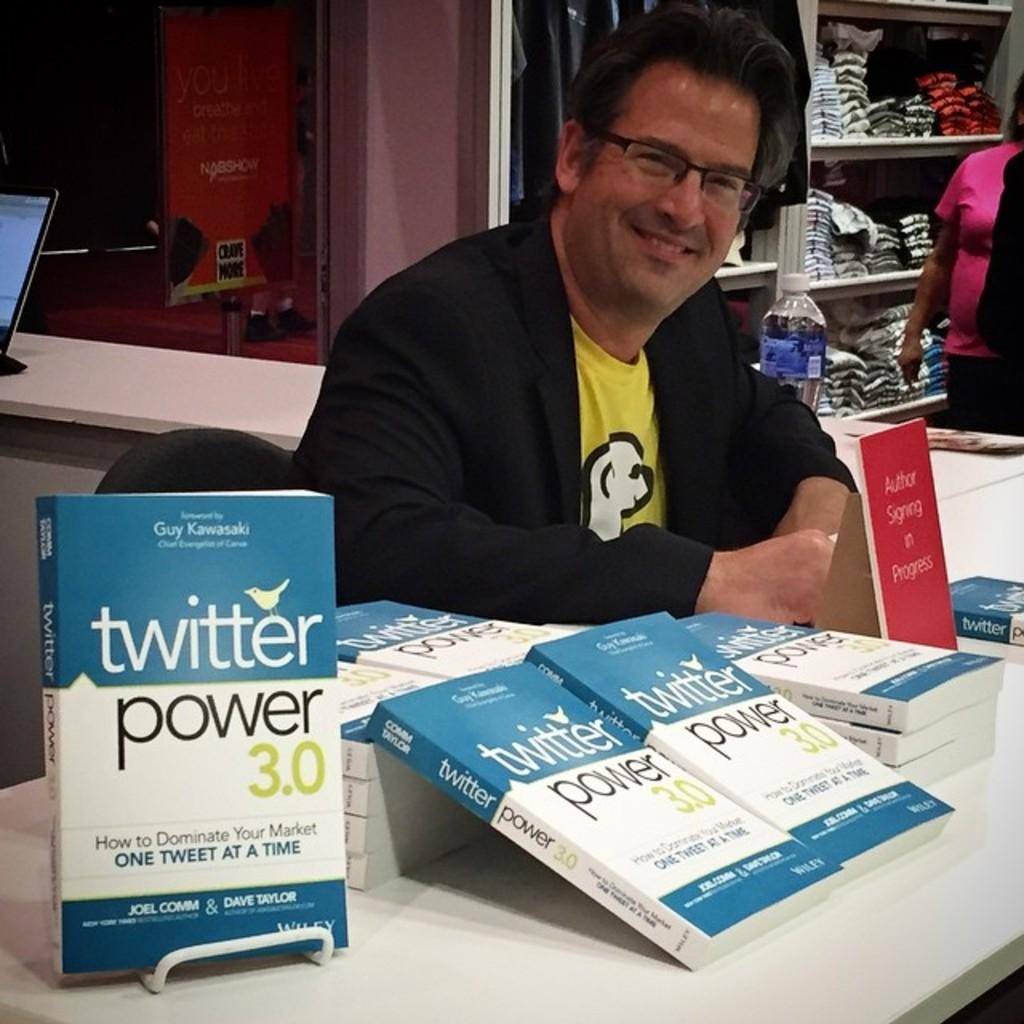<image>
Summarize the visual content of the image. A man sitting behind a table hawking books on Twitter marketing 